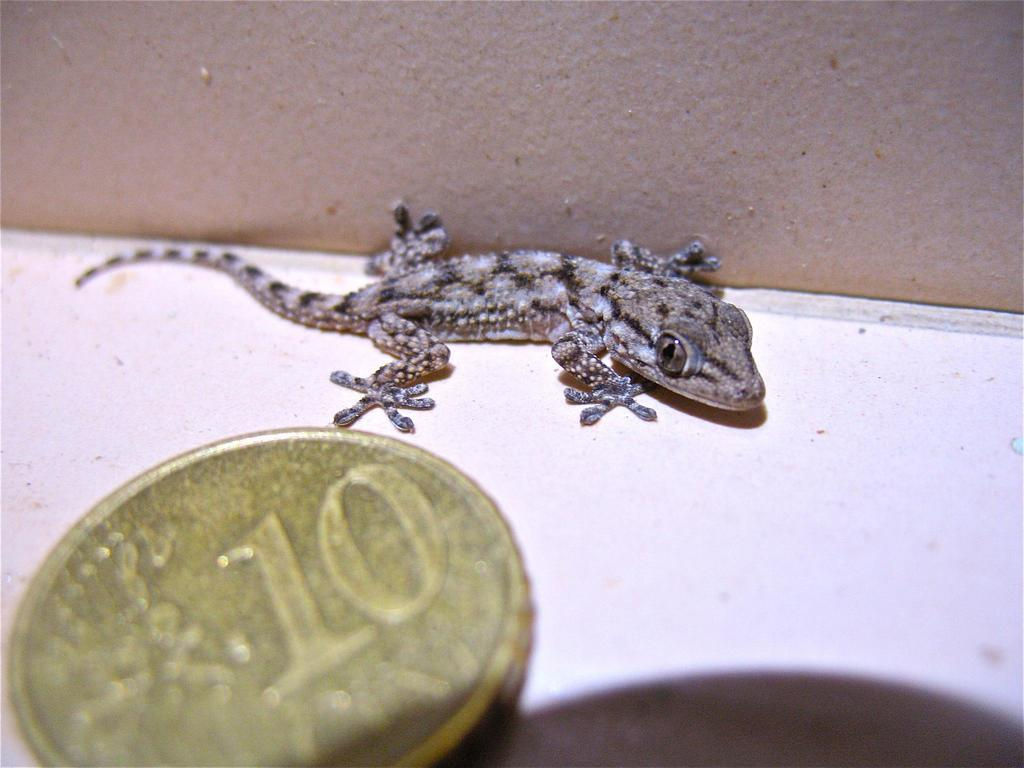What type of animal is in the image? There is a lizard in the image. What is the color of the surface the lizard is on? The lizard is on a white surface. What other object is visible in the image? There is a coin in the image. What number is on the coin? The coin has the number ten on it. What type of operation is being performed on the lizard in the image? There is no operation being performed on the lizard in the image. What statement is being made by the lizard in the image? The lizard is not making any statements in the image. 